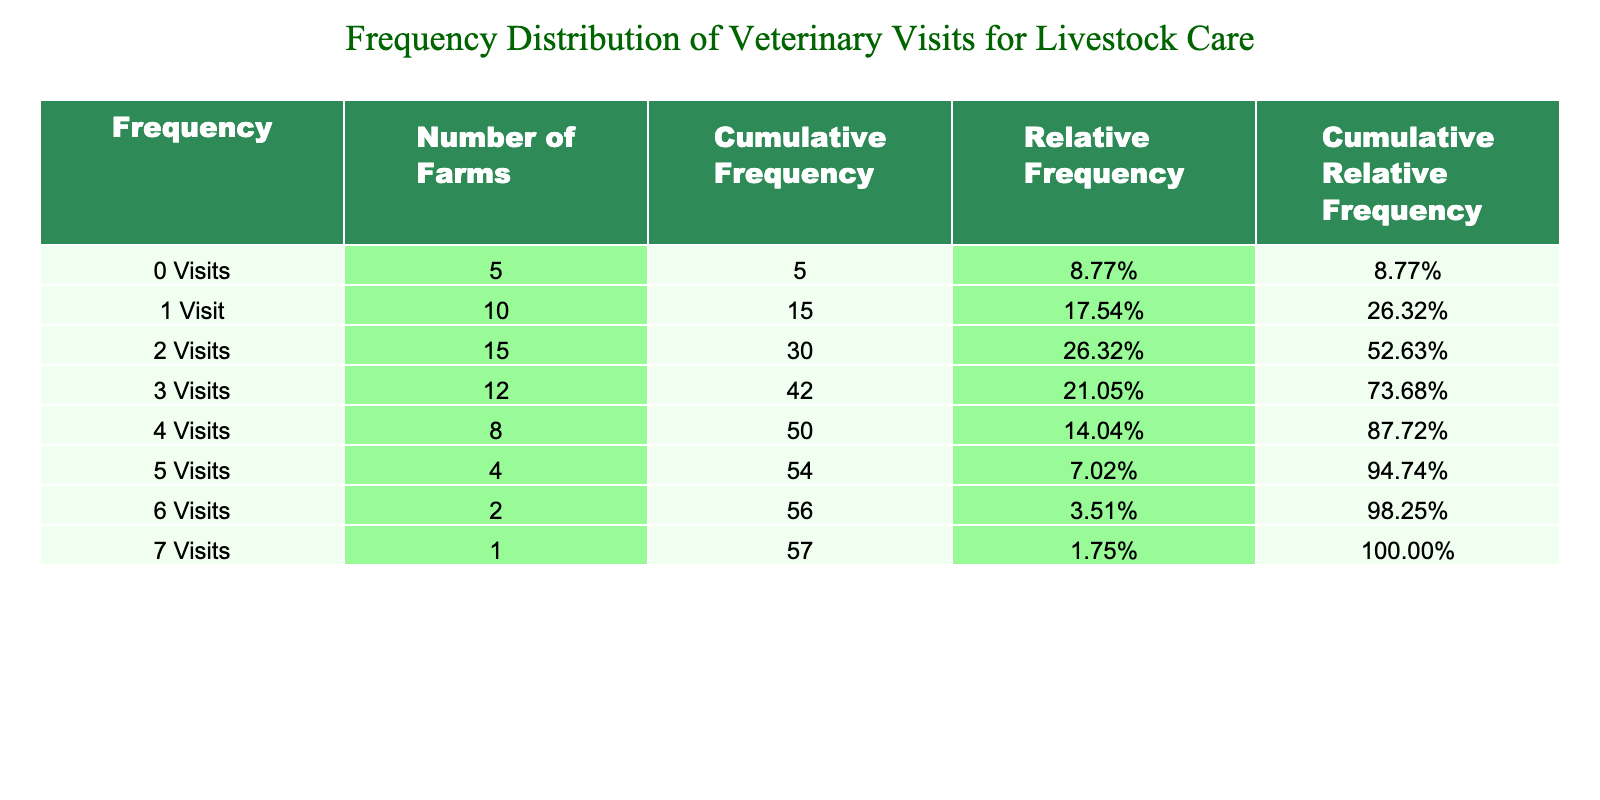What is the total number of farms that had three or more veterinary visits in the past year? To find the total number of farms with three or more visits, we add the number of farms for 3, 4, 5, 6, and 7 visits. These values are 12 (for 3 visits) + 8 (for 4 visits) + 4 (for 5 visits) + 2 (for 6 visits) + 1 (for 7 visits) = 27.
Answer: 27 What is the cumulative frequency of farms that had at least one veterinary visit? The cumulative frequency of farms with at least one visit can be found by summing the number of farms that had one visit and above: 10 (1 visit) + 15 (2 visits) + 12 (3 visits) + 8 (4 visits) + 4 (5 visits) + 2 (6 visits) + 1 (7 visits) = 52.
Answer: 52 How many farms did not have any veterinary visits in the past year? The number of farms that did not have any veterinary visits is directly provided in the table under "0 Visits," which lists 5 farms.
Answer: 5 What is the proportion of farms that had 0 visits compared to the total number of farms? The total number of farms is calculated by summing all the farms across the visits: 5 (0 visits) + 10 (1 visit) + 15 (2 visits) + 12 (3 visits) + 8 (4 visits) + 4 (5 visits) + 2 (6 visits) + 1 (7 visits) = 57. The proportion of farms with 0 visits is then 5 / 57, which approximately equals 0.0877 or 8.77%.
Answer: 8.77% Is it true that the majority of farms had 2 visits or less? To determine if this statement is true, we add the number of farms with 0, 1, and 2 visits: 5 (0 visits) + 10 (1 visit) + 15 (2 visits) = 30. The remaining farms with 3 visits or more total 27 (from previous calculations), which means 30 is greater than 27. Thus, the majority of farms did indeed have 2 visits or fewer.
Answer: Yes What is the average number of veterinary visits per farm? To calculate the average, we first find the total number of visits: (0 * 5) + (1 * 10) + (2 * 15) + (3 * 12) + (4 * 8) + (5 * 4) + (6 * 2) + (7 * 1) = 0 + 10 + 30 + 36 + 32 + 20 + 12 + 7 = 147. The average is then the total visits (147) divided by the total number of farms (57). So, 147 / 57 is approximately 2.58.
Answer: 2.58 